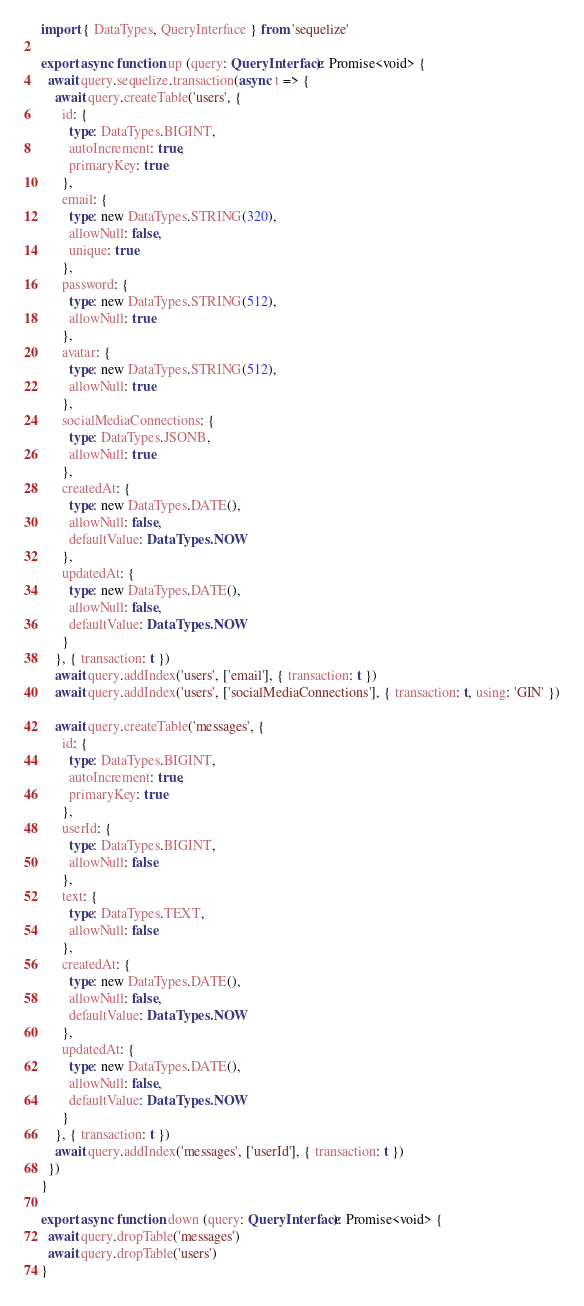Convert code to text. <code><loc_0><loc_0><loc_500><loc_500><_TypeScript_>import { DataTypes, QueryInterface } from 'sequelize'

export async function up (query: QueryInterface): Promise<void> {
  await query.sequelize.transaction(async t => {
    await query.createTable('users', {
      id: {
        type: DataTypes.BIGINT,
        autoIncrement: true,
        primaryKey: true
      },
      email: {
        type: new DataTypes.STRING(320),
        allowNull: false,
        unique: true
      },
      password: {
        type: new DataTypes.STRING(512),
        allowNull: true
      },
      avatar: {
        type: new DataTypes.STRING(512),
        allowNull: true
      },
      socialMediaConnections: {
        type: DataTypes.JSONB,
        allowNull: true
      },
      createdAt: {
        type: new DataTypes.DATE(),
        allowNull: false,
        defaultValue: DataTypes.NOW
      },
      updatedAt: {
        type: new DataTypes.DATE(),
        allowNull: false,
        defaultValue: DataTypes.NOW
      }
    }, { transaction: t })
    await query.addIndex('users', ['email'], { transaction: t })
    await query.addIndex('users', ['socialMediaConnections'], { transaction: t, using: 'GIN' })

    await query.createTable('messages', {
      id: {
        type: DataTypes.BIGINT,
        autoIncrement: true,
        primaryKey: true
      },
      userId: {
        type: DataTypes.BIGINT,
        allowNull: false
      },
      text: {
        type: DataTypes.TEXT,
        allowNull: false
      },
      createdAt: {
        type: new DataTypes.DATE(),
        allowNull: false,
        defaultValue: DataTypes.NOW
      },
      updatedAt: {
        type: new DataTypes.DATE(),
        allowNull: false,
        defaultValue: DataTypes.NOW
      }
    }, { transaction: t })
    await query.addIndex('messages', ['userId'], { transaction: t })
  })
}

export async function down (query: QueryInterface): Promise<void> {
  await query.dropTable('messages')
  await query.dropTable('users')
}
</code> 